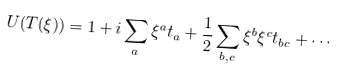Convert formula to latex. <formula><loc_0><loc_0><loc_500><loc_500>U ( T ( \xi ) ) = 1 + i \sum _ { a } \xi ^ { a } t _ { a } + { \frac { 1 } { 2 } } \sum _ { b , c } \xi ^ { b } \xi ^ { c } t _ { b c } + \cdots</formula> 